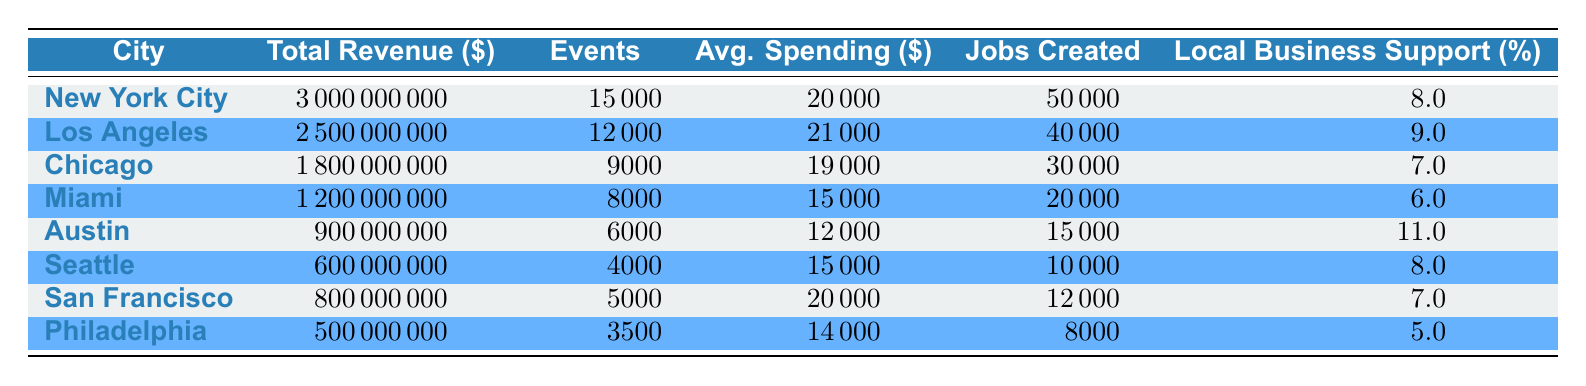What city had the highest total revenue from nightlife in 2022? The total revenue figures can be found in the first column for each city. New York City has a total revenue of 3 billion dollars, which is higher than any other city listed.
Answer: New York City Which city had the fewest jobs created from nightlife activities in 2022? The jobs created are listed in the last column for each city. Looking at the numbers, Philadelphia has 8,000 jobs created, which is the lowest among all the cities.
Answer: Philadelphia What was the average spending per event in Los Angeles? The average spending per event is listed in the corresponding column for Los Angeles. It shows $21,000 as the average spending per event.
Answer: 21000 Calculate the total revenue for cities where local business support is greater than 8%. The cities with local business support greater than 8% are Los Angeles (9%), and Austin (11%). Adding their total revenue: 2.5 billion + 0.9 billion = 3.4 billion dollars.
Answer: 3400000000 Did Chicago have a higher average spending per event than Miami? The average spending per event for Chicago is $19,000, while for Miami, it is $15,000. Since $19,000 is greater than $15,000, the statement is true.
Answer: Yes Which city has the highest local business support percentage? The local business support percentages are listed, with Austin at 11%, which is higher than all other cities, making it the city with the highest percentage.
Answer: Austin What is the difference in total revenue between New York City and San Francisco? Total revenue for New York City is $3 billion and for San Francisco is $800 million. The difference is calculated by subtracting: 3 billion - 800 million = 2.2 billion dollars.
Answer: 2200000000 Which city had more events: Chicago or Miami? The number of events for Chicago is listed as 9,000 and for Miami, it is 8,000. Comparing these values, Chicago had more events than Miami.
Answer: Chicago What percentage of local business support does Philadelphia have? The local business support figure for Philadelphia is found in the respective column, showing 5%.
Answer: 5 